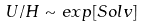<formula> <loc_0><loc_0><loc_500><loc_500>U / H \sim e x p [ S o l v ]</formula> 